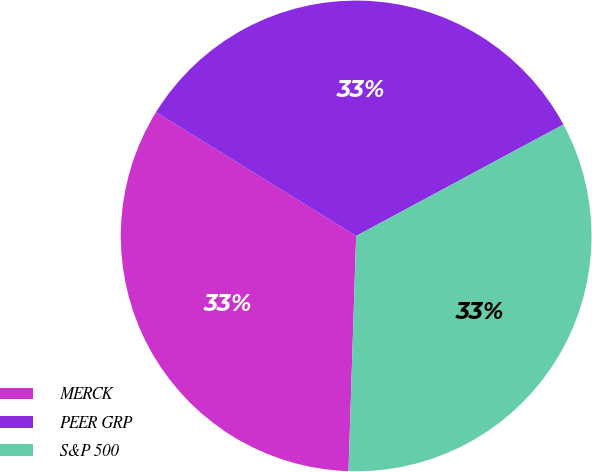Convert chart to OTSL. <chart><loc_0><loc_0><loc_500><loc_500><pie_chart><fcel>MERCK<fcel>PEER GRP<fcel>S&P 500<nl><fcel>33.3%<fcel>33.33%<fcel>33.37%<nl></chart> 